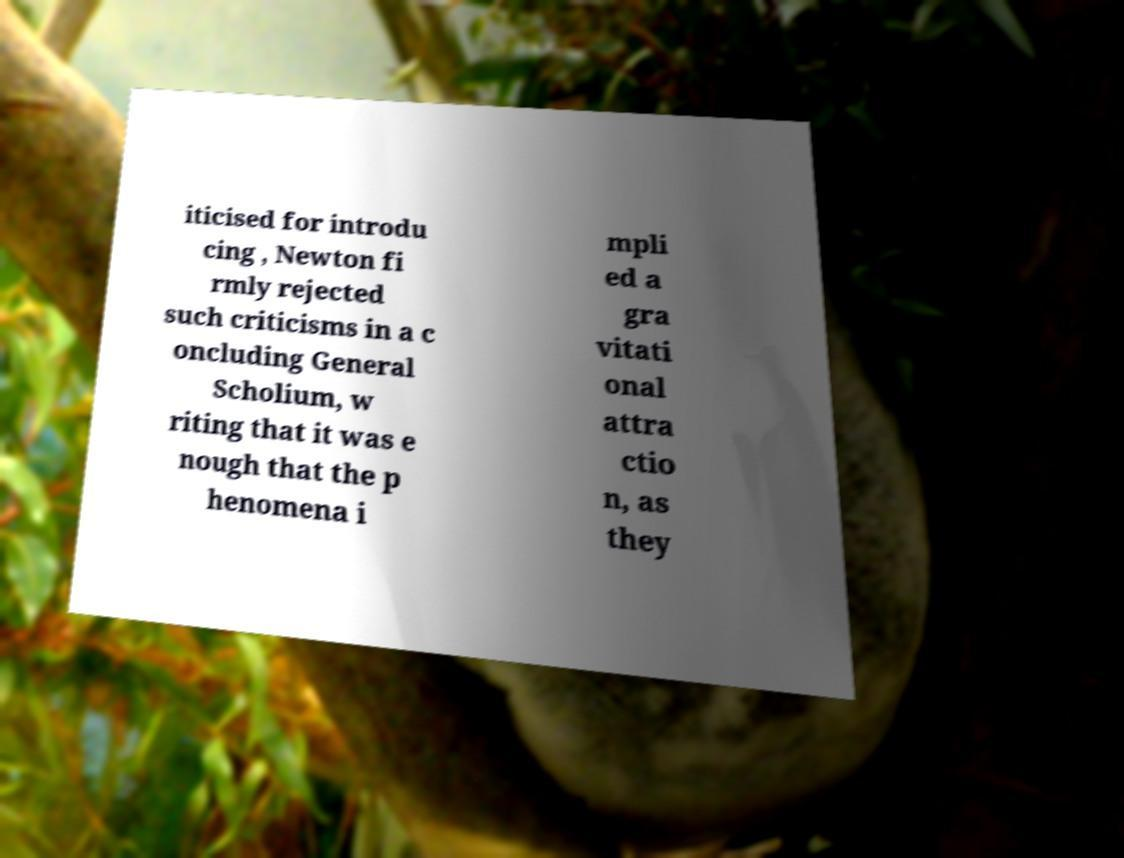Can you accurately transcribe the text from the provided image for me? iticised for introdu cing , Newton fi rmly rejected such criticisms in a c oncluding General Scholium, w riting that it was e nough that the p henomena i mpli ed a gra vitati onal attra ctio n, as they 